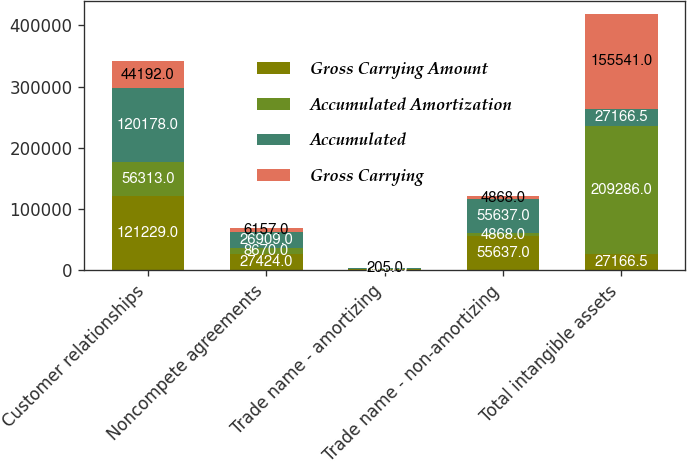Convert chart. <chart><loc_0><loc_0><loc_500><loc_500><stacked_bar_chart><ecel><fcel>Customer relationships<fcel>Noncompete agreements<fcel>Trade name - amortizing<fcel>Trade name - non-amortizing<fcel>Total intangible assets<nl><fcel>Gross Carrying Amount<fcel>121229<fcel>27424<fcel>1450<fcel>55637<fcel>27166.5<nl><fcel>Accumulated Amortization<fcel>56313<fcel>8670<fcel>926<fcel>4868<fcel>209286<nl><fcel>Accumulated<fcel>120178<fcel>26909<fcel>1450<fcel>55637<fcel>27166.5<nl><fcel>Gross Carrying<fcel>44192<fcel>6157<fcel>205<fcel>4868<fcel>155541<nl></chart> 